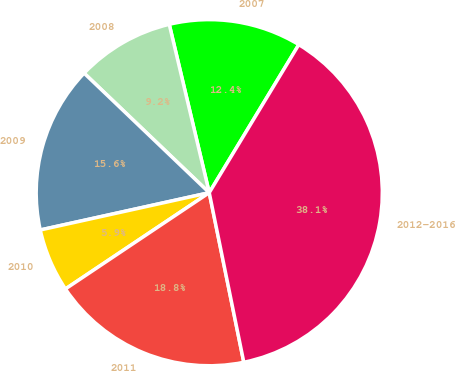Convert chart to OTSL. <chart><loc_0><loc_0><loc_500><loc_500><pie_chart><fcel>2007<fcel>2008<fcel>2009<fcel>2010<fcel>2011<fcel>2012-2016<nl><fcel>12.37%<fcel>9.15%<fcel>15.59%<fcel>5.93%<fcel>18.81%<fcel>38.14%<nl></chart> 